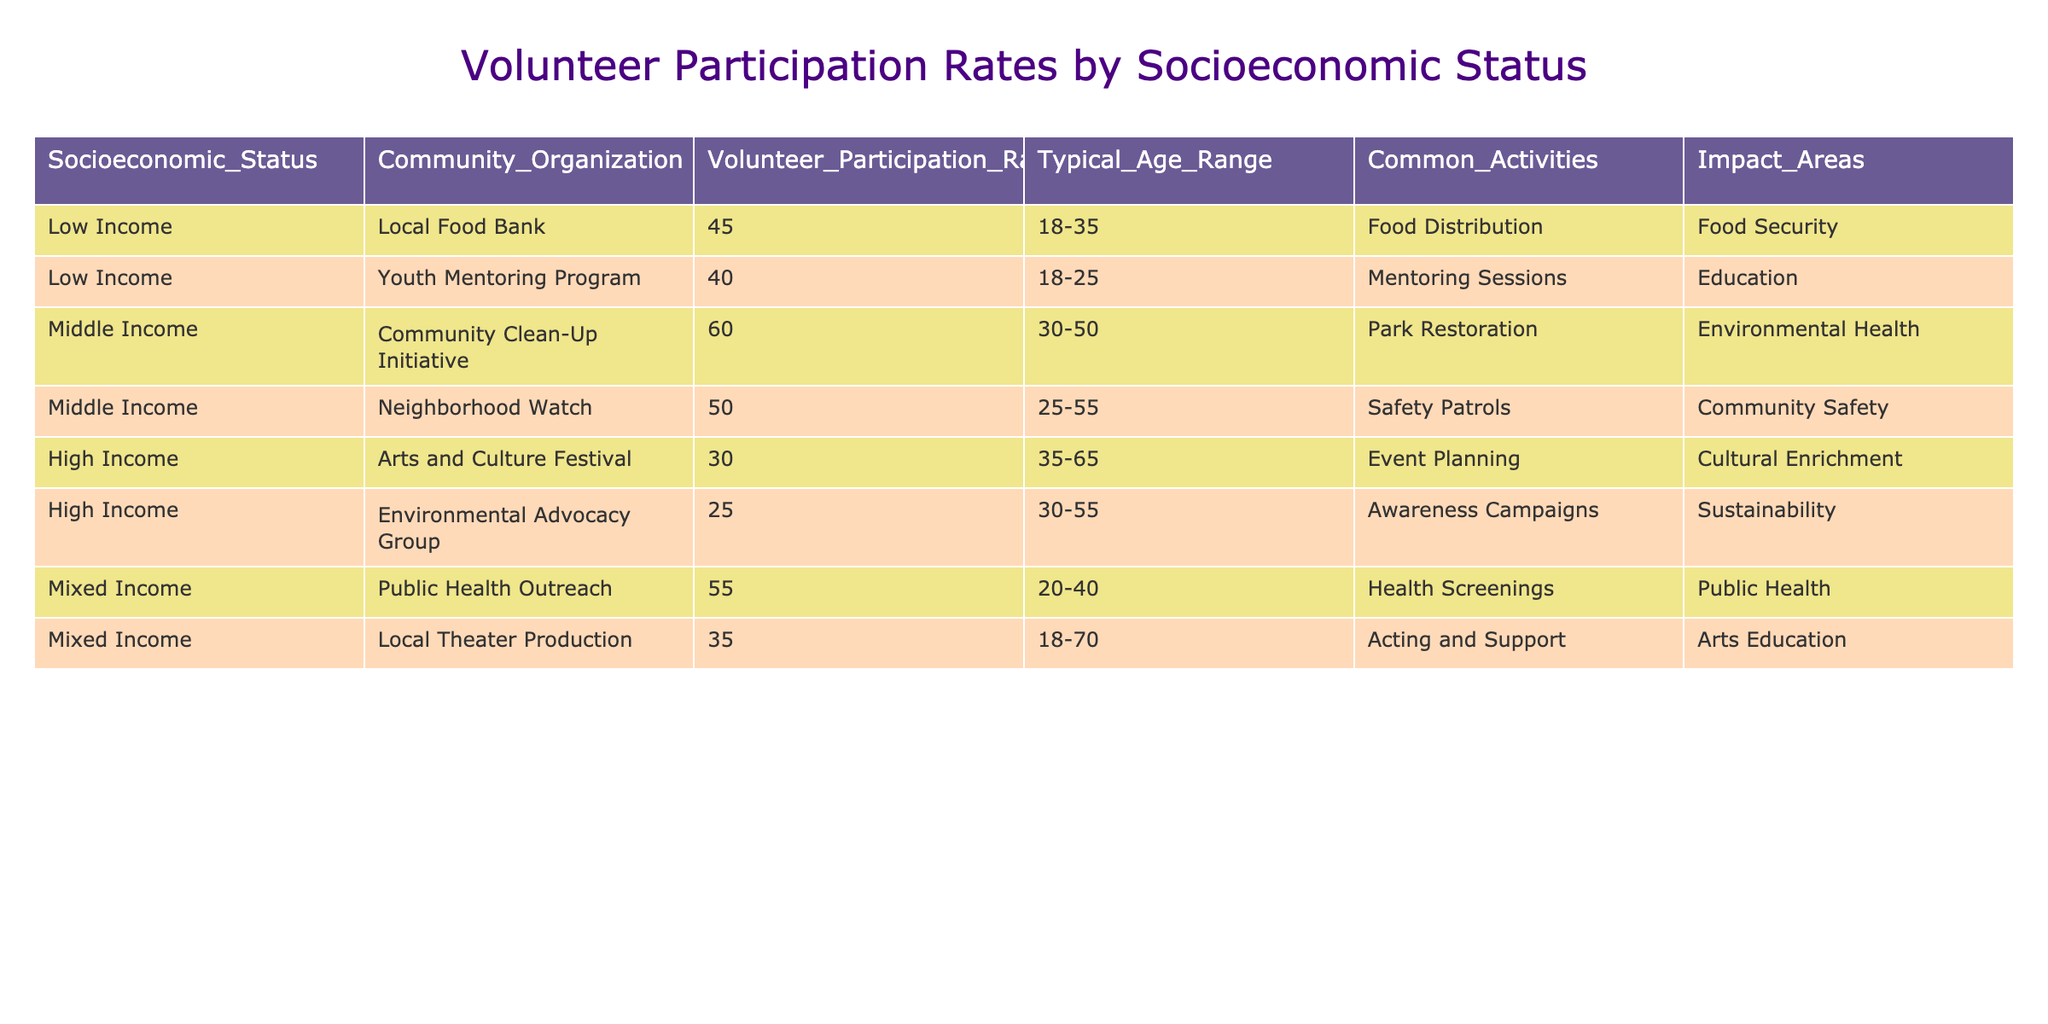What is the volunteer participation rate for the Youth Mentoring Program? The table shows a participation rate of 40% for the Youth Mentoring Program, which is indicated in the corresponding row under the "Volunteer Participation Rate(%)" column.
Answer: 40% Which community organization with a Low Income status has the highest volunteer participation rate? The Local Food Bank has the highest volunteer participation rate of 45% among the Low Income community organizations, as seen in the table's "Volunteer Participation Rate(%)" column.
Answer: Local Food Bank What is the average volunteer participation rate for Middle Income organizations? There are two Middle Income organizations: the Community Clean-Up Initiative (60%) and Neighborhood Watch (50%). Adding these rates gives 60 + 50 = 110, and dividing by the number of organizations (2) gives an average of 110/2 = 55%.
Answer: 55% Is the volunteer participation rate for High Income organizations generally lower than that for Low Income organizations? The average participation rate for High Income organizations is (30 + 25)/2 = 27.5%, while the average for Low Income organizations is (45 + 40)/2 = 42.5%. Since 27.5% is less than 42.5%, the statement is true.
Answer: Yes Which socioeconomic status has the highest volunteer participation rate across all community organizations? The Mixed Income category has the highest individual participation rate at 55% for the Public Health Outreach, which is greater than the maximum rates for Low Income (45%), Middle Income (60%), and High Income (30%).
Answer: Mixed Income 